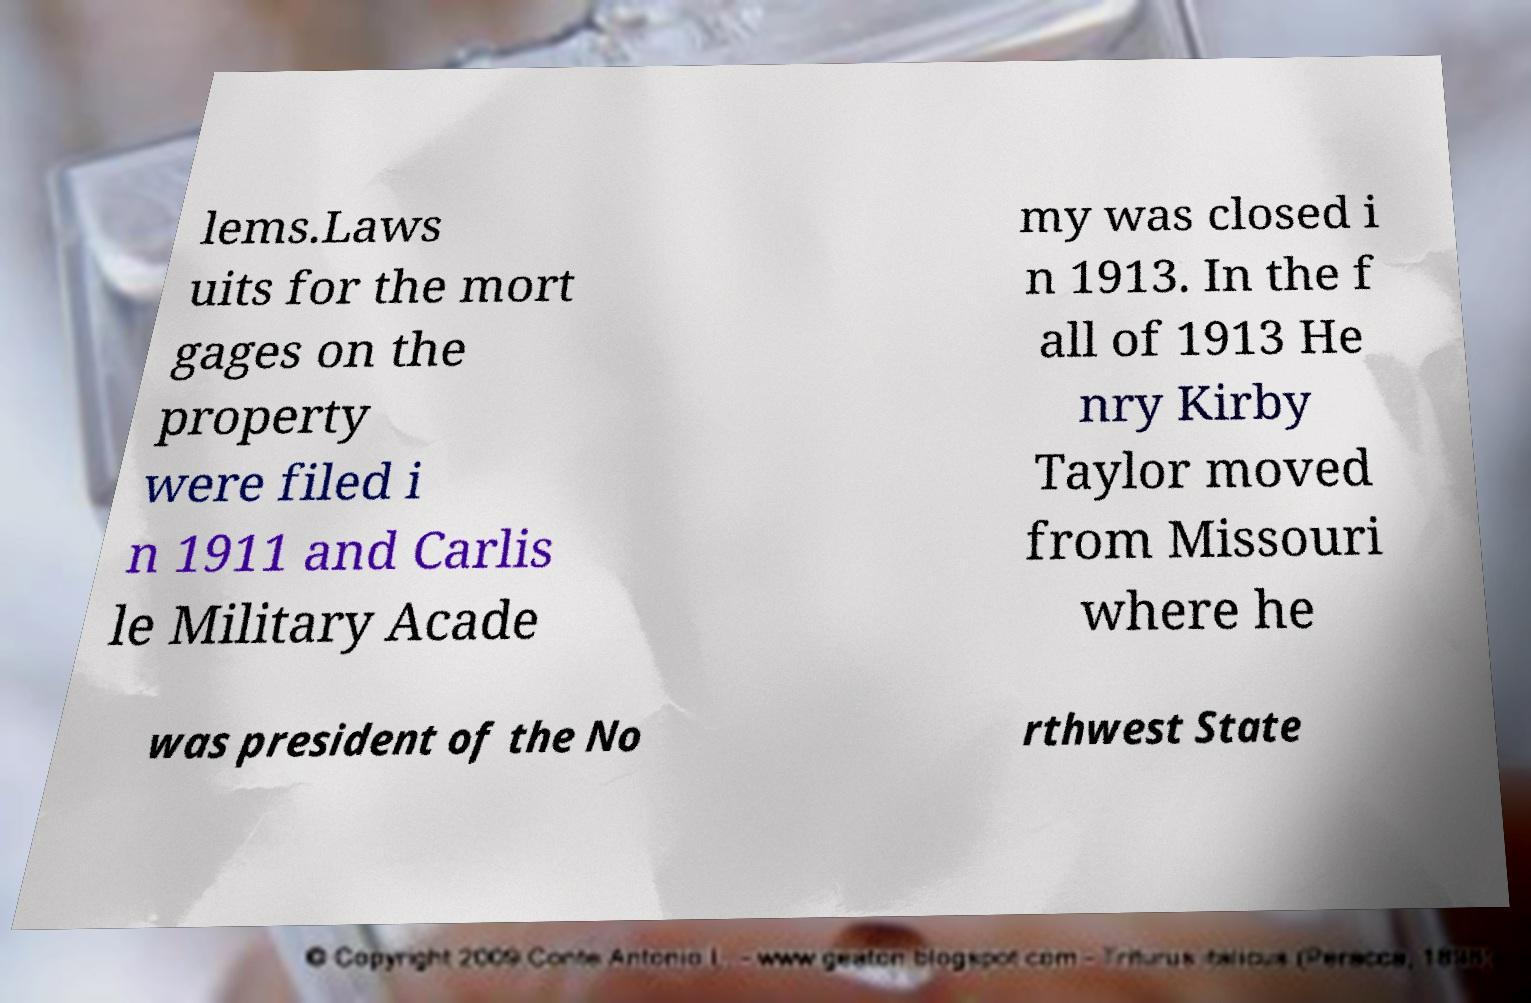Can you accurately transcribe the text from the provided image for me? lems.Laws uits for the mort gages on the property were filed i n 1911 and Carlis le Military Acade my was closed i n 1913. In the f all of 1913 He nry Kirby Taylor moved from Missouri where he was president of the No rthwest State 